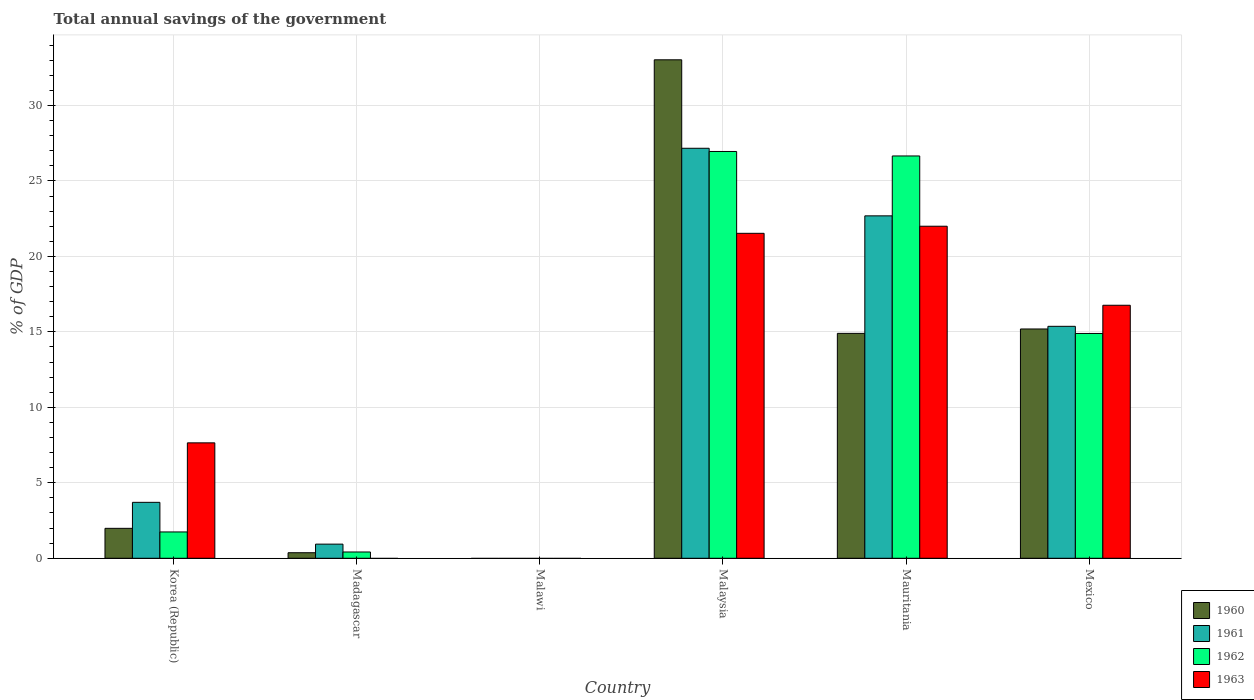How many different coloured bars are there?
Offer a very short reply. 4. Are the number of bars on each tick of the X-axis equal?
Give a very brief answer. No. How many bars are there on the 1st tick from the left?
Your answer should be compact. 4. How many bars are there on the 1st tick from the right?
Your answer should be compact. 4. In how many cases, is the number of bars for a given country not equal to the number of legend labels?
Provide a succinct answer. 2. What is the total annual savings of the government in 1962 in Korea (Republic)?
Give a very brief answer. 1.74. Across all countries, what is the maximum total annual savings of the government in 1962?
Give a very brief answer. 26.95. In which country was the total annual savings of the government in 1960 maximum?
Provide a short and direct response. Malaysia. What is the total total annual savings of the government in 1960 in the graph?
Offer a terse response. 65.47. What is the difference between the total annual savings of the government in 1960 in Korea (Republic) and that in Mexico?
Keep it short and to the point. -13.21. What is the difference between the total annual savings of the government in 1961 in Mexico and the total annual savings of the government in 1960 in Malaysia?
Make the answer very short. -17.66. What is the average total annual savings of the government in 1963 per country?
Provide a succinct answer. 11.32. What is the difference between the total annual savings of the government of/in 1961 and total annual savings of the government of/in 1960 in Korea (Republic)?
Give a very brief answer. 1.72. In how many countries, is the total annual savings of the government in 1961 greater than 30 %?
Keep it short and to the point. 0. What is the ratio of the total annual savings of the government in 1961 in Madagascar to that in Mexico?
Make the answer very short. 0.06. Is the total annual savings of the government in 1961 in Madagascar less than that in Mexico?
Provide a short and direct response. Yes. Is the difference between the total annual savings of the government in 1961 in Malaysia and Mauritania greater than the difference between the total annual savings of the government in 1960 in Malaysia and Mauritania?
Your response must be concise. No. What is the difference between the highest and the second highest total annual savings of the government in 1960?
Your answer should be very brief. 18.13. What is the difference between the highest and the lowest total annual savings of the government in 1960?
Keep it short and to the point. 33.03. Is the sum of the total annual savings of the government in 1962 in Korea (Republic) and Malaysia greater than the maximum total annual savings of the government in 1961 across all countries?
Keep it short and to the point. Yes. Is it the case that in every country, the sum of the total annual savings of the government in 1961 and total annual savings of the government in 1962 is greater than the total annual savings of the government in 1960?
Keep it short and to the point. No. What is the difference between two consecutive major ticks on the Y-axis?
Give a very brief answer. 5. Does the graph contain grids?
Your answer should be compact. Yes. Where does the legend appear in the graph?
Ensure brevity in your answer.  Bottom right. How are the legend labels stacked?
Ensure brevity in your answer.  Vertical. What is the title of the graph?
Provide a short and direct response. Total annual savings of the government. What is the label or title of the X-axis?
Provide a succinct answer. Country. What is the label or title of the Y-axis?
Keep it short and to the point. % of GDP. What is the % of GDP in 1960 in Korea (Republic)?
Offer a very short reply. 1.98. What is the % of GDP in 1961 in Korea (Republic)?
Provide a succinct answer. 3.71. What is the % of GDP of 1962 in Korea (Republic)?
Give a very brief answer. 1.74. What is the % of GDP of 1963 in Korea (Republic)?
Provide a short and direct response. 7.65. What is the % of GDP of 1960 in Madagascar?
Keep it short and to the point. 0.37. What is the % of GDP of 1961 in Madagascar?
Your answer should be compact. 0.94. What is the % of GDP of 1962 in Madagascar?
Your response must be concise. 0.42. What is the % of GDP in 1963 in Madagascar?
Your answer should be compact. 0. What is the % of GDP of 1960 in Malawi?
Your response must be concise. 0. What is the % of GDP in 1961 in Malawi?
Keep it short and to the point. 0. What is the % of GDP of 1960 in Malaysia?
Ensure brevity in your answer.  33.03. What is the % of GDP in 1961 in Malaysia?
Your answer should be very brief. 27.16. What is the % of GDP in 1962 in Malaysia?
Your answer should be compact. 26.95. What is the % of GDP in 1963 in Malaysia?
Your response must be concise. 21.53. What is the % of GDP of 1960 in Mauritania?
Your answer should be very brief. 14.9. What is the % of GDP in 1961 in Mauritania?
Offer a very short reply. 22.69. What is the % of GDP in 1962 in Mauritania?
Provide a short and direct response. 26.65. What is the % of GDP in 1963 in Mauritania?
Ensure brevity in your answer.  22. What is the % of GDP in 1960 in Mexico?
Ensure brevity in your answer.  15.19. What is the % of GDP of 1961 in Mexico?
Your answer should be very brief. 15.37. What is the % of GDP of 1962 in Mexico?
Offer a very short reply. 14.89. What is the % of GDP of 1963 in Mexico?
Provide a short and direct response. 16.76. Across all countries, what is the maximum % of GDP in 1960?
Your answer should be very brief. 33.03. Across all countries, what is the maximum % of GDP in 1961?
Your answer should be very brief. 27.16. Across all countries, what is the maximum % of GDP of 1962?
Give a very brief answer. 26.95. Across all countries, what is the maximum % of GDP in 1963?
Your answer should be very brief. 22. Across all countries, what is the minimum % of GDP in 1961?
Ensure brevity in your answer.  0. Across all countries, what is the minimum % of GDP in 1962?
Your answer should be very brief. 0. Across all countries, what is the minimum % of GDP in 1963?
Your response must be concise. 0. What is the total % of GDP of 1960 in the graph?
Provide a succinct answer. 65.47. What is the total % of GDP of 1961 in the graph?
Offer a terse response. 69.86. What is the total % of GDP in 1962 in the graph?
Provide a short and direct response. 70.66. What is the total % of GDP in 1963 in the graph?
Offer a terse response. 67.94. What is the difference between the % of GDP in 1960 in Korea (Republic) and that in Madagascar?
Your response must be concise. 1.62. What is the difference between the % of GDP in 1961 in Korea (Republic) and that in Madagascar?
Make the answer very short. 2.77. What is the difference between the % of GDP of 1962 in Korea (Republic) and that in Madagascar?
Provide a succinct answer. 1.33. What is the difference between the % of GDP of 1960 in Korea (Republic) and that in Malaysia?
Offer a very short reply. -31.04. What is the difference between the % of GDP of 1961 in Korea (Republic) and that in Malaysia?
Make the answer very short. -23.46. What is the difference between the % of GDP of 1962 in Korea (Republic) and that in Malaysia?
Give a very brief answer. -25.21. What is the difference between the % of GDP of 1963 in Korea (Republic) and that in Malaysia?
Offer a very short reply. -13.88. What is the difference between the % of GDP of 1960 in Korea (Republic) and that in Mauritania?
Keep it short and to the point. -12.92. What is the difference between the % of GDP in 1961 in Korea (Republic) and that in Mauritania?
Provide a short and direct response. -18.98. What is the difference between the % of GDP of 1962 in Korea (Republic) and that in Mauritania?
Ensure brevity in your answer.  -24.91. What is the difference between the % of GDP in 1963 in Korea (Republic) and that in Mauritania?
Your answer should be compact. -14.35. What is the difference between the % of GDP of 1960 in Korea (Republic) and that in Mexico?
Your answer should be compact. -13.21. What is the difference between the % of GDP of 1961 in Korea (Republic) and that in Mexico?
Offer a terse response. -11.66. What is the difference between the % of GDP of 1962 in Korea (Republic) and that in Mexico?
Your answer should be very brief. -13.15. What is the difference between the % of GDP in 1963 in Korea (Republic) and that in Mexico?
Give a very brief answer. -9.12. What is the difference between the % of GDP of 1960 in Madagascar and that in Malaysia?
Offer a very short reply. -32.66. What is the difference between the % of GDP in 1961 in Madagascar and that in Malaysia?
Make the answer very short. -26.23. What is the difference between the % of GDP in 1962 in Madagascar and that in Malaysia?
Your response must be concise. -26.53. What is the difference between the % of GDP in 1960 in Madagascar and that in Mauritania?
Your answer should be compact. -14.53. What is the difference between the % of GDP in 1961 in Madagascar and that in Mauritania?
Keep it short and to the point. -21.75. What is the difference between the % of GDP in 1962 in Madagascar and that in Mauritania?
Offer a terse response. -26.24. What is the difference between the % of GDP of 1960 in Madagascar and that in Mexico?
Your answer should be very brief. -14.82. What is the difference between the % of GDP in 1961 in Madagascar and that in Mexico?
Your answer should be compact. -14.43. What is the difference between the % of GDP of 1962 in Madagascar and that in Mexico?
Your response must be concise. -14.48. What is the difference between the % of GDP in 1960 in Malaysia and that in Mauritania?
Offer a terse response. 18.13. What is the difference between the % of GDP in 1961 in Malaysia and that in Mauritania?
Give a very brief answer. 4.48. What is the difference between the % of GDP of 1962 in Malaysia and that in Mauritania?
Your answer should be very brief. 0.3. What is the difference between the % of GDP in 1963 in Malaysia and that in Mauritania?
Offer a terse response. -0.47. What is the difference between the % of GDP of 1960 in Malaysia and that in Mexico?
Offer a terse response. 17.83. What is the difference between the % of GDP in 1961 in Malaysia and that in Mexico?
Your response must be concise. 11.8. What is the difference between the % of GDP in 1962 in Malaysia and that in Mexico?
Give a very brief answer. 12.06. What is the difference between the % of GDP in 1963 in Malaysia and that in Mexico?
Offer a terse response. 4.77. What is the difference between the % of GDP of 1960 in Mauritania and that in Mexico?
Make the answer very short. -0.29. What is the difference between the % of GDP of 1961 in Mauritania and that in Mexico?
Give a very brief answer. 7.32. What is the difference between the % of GDP in 1962 in Mauritania and that in Mexico?
Provide a succinct answer. 11.76. What is the difference between the % of GDP in 1963 in Mauritania and that in Mexico?
Provide a succinct answer. 5.24. What is the difference between the % of GDP in 1960 in Korea (Republic) and the % of GDP in 1961 in Madagascar?
Your answer should be very brief. 1.05. What is the difference between the % of GDP of 1960 in Korea (Republic) and the % of GDP of 1962 in Madagascar?
Make the answer very short. 1.57. What is the difference between the % of GDP of 1961 in Korea (Republic) and the % of GDP of 1962 in Madagascar?
Keep it short and to the point. 3.29. What is the difference between the % of GDP in 1960 in Korea (Republic) and the % of GDP in 1961 in Malaysia?
Keep it short and to the point. -25.18. What is the difference between the % of GDP in 1960 in Korea (Republic) and the % of GDP in 1962 in Malaysia?
Give a very brief answer. -24.97. What is the difference between the % of GDP in 1960 in Korea (Republic) and the % of GDP in 1963 in Malaysia?
Your answer should be compact. -19.55. What is the difference between the % of GDP of 1961 in Korea (Republic) and the % of GDP of 1962 in Malaysia?
Provide a succinct answer. -23.24. What is the difference between the % of GDP in 1961 in Korea (Republic) and the % of GDP in 1963 in Malaysia?
Offer a terse response. -17.82. What is the difference between the % of GDP in 1962 in Korea (Republic) and the % of GDP in 1963 in Malaysia?
Your answer should be very brief. -19.79. What is the difference between the % of GDP of 1960 in Korea (Republic) and the % of GDP of 1961 in Mauritania?
Your answer should be compact. -20.7. What is the difference between the % of GDP in 1960 in Korea (Republic) and the % of GDP in 1962 in Mauritania?
Your answer should be compact. -24.67. What is the difference between the % of GDP of 1960 in Korea (Republic) and the % of GDP of 1963 in Mauritania?
Your answer should be compact. -20.02. What is the difference between the % of GDP of 1961 in Korea (Republic) and the % of GDP of 1962 in Mauritania?
Make the answer very short. -22.95. What is the difference between the % of GDP in 1961 in Korea (Republic) and the % of GDP in 1963 in Mauritania?
Your response must be concise. -18.29. What is the difference between the % of GDP in 1962 in Korea (Republic) and the % of GDP in 1963 in Mauritania?
Offer a terse response. -20.25. What is the difference between the % of GDP of 1960 in Korea (Republic) and the % of GDP of 1961 in Mexico?
Give a very brief answer. -13.38. What is the difference between the % of GDP of 1960 in Korea (Republic) and the % of GDP of 1962 in Mexico?
Keep it short and to the point. -12.91. What is the difference between the % of GDP of 1960 in Korea (Republic) and the % of GDP of 1963 in Mexico?
Provide a short and direct response. -14.78. What is the difference between the % of GDP in 1961 in Korea (Republic) and the % of GDP in 1962 in Mexico?
Provide a succinct answer. -11.19. What is the difference between the % of GDP of 1961 in Korea (Republic) and the % of GDP of 1963 in Mexico?
Provide a short and direct response. -13.06. What is the difference between the % of GDP in 1962 in Korea (Republic) and the % of GDP in 1963 in Mexico?
Your response must be concise. -15.02. What is the difference between the % of GDP of 1960 in Madagascar and the % of GDP of 1961 in Malaysia?
Provide a succinct answer. -26.8. What is the difference between the % of GDP of 1960 in Madagascar and the % of GDP of 1962 in Malaysia?
Ensure brevity in your answer.  -26.58. What is the difference between the % of GDP of 1960 in Madagascar and the % of GDP of 1963 in Malaysia?
Your answer should be compact. -21.16. What is the difference between the % of GDP of 1961 in Madagascar and the % of GDP of 1962 in Malaysia?
Make the answer very short. -26.01. What is the difference between the % of GDP of 1961 in Madagascar and the % of GDP of 1963 in Malaysia?
Offer a very short reply. -20.59. What is the difference between the % of GDP of 1962 in Madagascar and the % of GDP of 1963 in Malaysia?
Provide a short and direct response. -21.11. What is the difference between the % of GDP of 1960 in Madagascar and the % of GDP of 1961 in Mauritania?
Your answer should be very brief. -22.32. What is the difference between the % of GDP in 1960 in Madagascar and the % of GDP in 1962 in Mauritania?
Your answer should be compact. -26.29. What is the difference between the % of GDP in 1960 in Madagascar and the % of GDP in 1963 in Mauritania?
Your answer should be compact. -21.63. What is the difference between the % of GDP of 1961 in Madagascar and the % of GDP of 1962 in Mauritania?
Make the answer very short. -25.72. What is the difference between the % of GDP of 1961 in Madagascar and the % of GDP of 1963 in Mauritania?
Your answer should be compact. -21.06. What is the difference between the % of GDP in 1962 in Madagascar and the % of GDP in 1963 in Mauritania?
Give a very brief answer. -21.58. What is the difference between the % of GDP of 1960 in Madagascar and the % of GDP of 1961 in Mexico?
Your answer should be compact. -15. What is the difference between the % of GDP in 1960 in Madagascar and the % of GDP in 1962 in Mexico?
Offer a very short reply. -14.53. What is the difference between the % of GDP of 1960 in Madagascar and the % of GDP of 1963 in Mexico?
Provide a short and direct response. -16.4. What is the difference between the % of GDP in 1961 in Madagascar and the % of GDP in 1962 in Mexico?
Offer a terse response. -13.96. What is the difference between the % of GDP of 1961 in Madagascar and the % of GDP of 1963 in Mexico?
Offer a very short reply. -15.83. What is the difference between the % of GDP in 1962 in Madagascar and the % of GDP in 1963 in Mexico?
Keep it short and to the point. -16.35. What is the difference between the % of GDP in 1960 in Malaysia and the % of GDP in 1961 in Mauritania?
Your answer should be very brief. 10.34. What is the difference between the % of GDP in 1960 in Malaysia and the % of GDP in 1962 in Mauritania?
Make the answer very short. 6.37. What is the difference between the % of GDP of 1960 in Malaysia and the % of GDP of 1963 in Mauritania?
Give a very brief answer. 11.03. What is the difference between the % of GDP in 1961 in Malaysia and the % of GDP in 1962 in Mauritania?
Give a very brief answer. 0.51. What is the difference between the % of GDP in 1961 in Malaysia and the % of GDP in 1963 in Mauritania?
Offer a very short reply. 5.17. What is the difference between the % of GDP in 1962 in Malaysia and the % of GDP in 1963 in Mauritania?
Ensure brevity in your answer.  4.95. What is the difference between the % of GDP in 1960 in Malaysia and the % of GDP in 1961 in Mexico?
Keep it short and to the point. 17.66. What is the difference between the % of GDP in 1960 in Malaysia and the % of GDP in 1962 in Mexico?
Provide a short and direct response. 18.13. What is the difference between the % of GDP of 1960 in Malaysia and the % of GDP of 1963 in Mexico?
Keep it short and to the point. 16.26. What is the difference between the % of GDP in 1961 in Malaysia and the % of GDP in 1962 in Mexico?
Give a very brief answer. 12.27. What is the difference between the % of GDP of 1961 in Malaysia and the % of GDP of 1963 in Mexico?
Offer a very short reply. 10.4. What is the difference between the % of GDP of 1962 in Malaysia and the % of GDP of 1963 in Mexico?
Ensure brevity in your answer.  10.19. What is the difference between the % of GDP in 1960 in Mauritania and the % of GDP in 1961 in Mexico?
Provide a succinct answer. -0.47. What is the difference between the % of GDP in 1960 in Mauritania and the % of GDP in 1962 in Mexico?
Give a very brief answer. 0.01. What is the difference between the % of GDP of 1960 in Mauritania and the % of GDP of 1963 in Mexico?
Your response must be concise. -1.86. What is the difference between the % of GDP of 1961 in Mauritania and the % of GDP of 1962 in Mexico?
Offer a very short reply. 7.79. What is the difference between the % of GDP in 1961 in Mauritania and the % of GDP in 1963 in Mexico?
Keep it short and to the point. 5.92. What is the difference between the % of GDP of 1962 in Mauritania and the % of GDP of 1963 in Mexico?
Your answer should be compact. 9.89. What is the average % of GDP in 1960 per country?
Your answer should be very brief. 10.91. What is the average % of GDP of 1961 per country?
Ensure brevity in your answer.  11.64. What is the average % of GDP of 1962 per country?
Give a very brief answer. 11.78. What is the average % of GDP of 1963 per country?
Offer a terse response. 11.32. What is the difference between the % of GDP in 1960 and % of GDP in 1961 in Korea (Republic)?
Your response must be concise. -1.72. What is the difference between the % of GDP in 1960 and % of GDP in 1962 in Korea (Republic)?
Make the answer very short. 0.24. What is the difference between the % of GDP in 1960 and % of GDP in 1963 in Korea (Republic)?
Ensure brevity in your answer.  -5.66. What is the difference between the % of GDP in 1961 and % of GDP in 1962 in Korea (Republic)?
Give a very brief answer. 1.96. What is the difference between the % of GDP of 1961 and % of GDP of 1963 in Korea (Republic)?
Offer a terse response. -3.94. What is the difference between the % of GDP of 1962 and % of GDP of 1963 in Korea (Republic)?
Keep it short and to the point. -5.9. What is the difference between the % of GDP of 1960 and % of GDP of 1961 in Madagascar?
Keep it short and to the point. -0.57. What is the difference between the % of GDP in 1960 and % of GDP in 1962 in Madagascar?
Offer a terse response. -0.05. What is the difference between the % of GDP of 1961 and % of GDP of 1962 in Madagascar?
Provide a short and direct response. 0.52. What is the difference between the % of GDP of 1960 and % of GDP of 1961 in Malaysia?
Make the answer very short. 5.86. What is the difference between the % of GDP of 1960 and % of GDP of 1962 in Malaysia?
Provide a short and direct response. 6.07. What is the difference between the % of GDP in 1960 and % of GDP in 1963 in Malaysia?
Offer a very short reply. 11.5. What is the difference between the % of GDP of 1961 and % of GDP of 1962 in Malaysia?
Keep it short and to the point. 0.21. What is the difference between the % of GDP of 1961 and % of GDP of 1963 in Malaysia?
Provide a succinct answer. 5.63. What is the difference between the % of GDP of 1962 and % of GDP of 1963 in Malaysia?
Your answer should be compact. 5.42. What is the difference between the % of GDP in 1960 and % of GDP in 1961 in Mauritania?
Your answer should be very brief. -7.79. What is the difference between the % of GDP of 1960 and % of GDP of 1962 in Mauritania?
Your answer should be compact. -11.75. What is the difference between the % of GDP in 1960 and % of GDP in 1963 in Mauritania?
Provide a short and direct response. -7.1. What is the difference between the % of GDP in 1961 and % of GDP in 1962 in Mauritania?
Provide a succinct answer. -3.97. What is the difference between the % of GDP of 1961 and % of GDP of 1963 in Mauritania?
Make the answer very short. 0.69. What is the difference between the % of GDP in 1962 and % of GDP in 1963 in Mauritania?
Your response must be concise. 4.66. What is the difference between the % of GDP in 1960 and % of GDP in 1961 in Mexico?
Your response must be concise. -0.18. What is the difference between the % of GDP of 1960 and % of GDP of 1962 in Mexico?
Keep it short and to the point. 0.3. What is the difference between the % of GDP of 1960 and % of GDP of 1963 in Mexico?
Make the answer very short. -1.57. What is the difference between the % of GDP of 1961 and % of GDP of 1962 in Mexico?
Your answer should be compact. 0.47. What is the difference between the % of GDP of 1961 and % of GDP of 1963 in Mexico?
Give a very brief answer. -1.4. What is the difference between the % of GDP in 1962 and % of GDP in 1963 in Mexico?
Your answer should be very brief. -1.87. What is the ratio of the % of GDP of 1960 in Korea (Republic) to that in Madagascar?
Your answer should be very brief. 5.4. What is the ratio of the % of GDP of 1961 in Korea (Republic) to that in Madagascar?
Keep it short and to the point. 3.96. What is the ratio of the % of GDP in 1962 in Korea (Republic) to that in Madagascar?
Offer a very short reply. 4.19. What is the ratio of the % of GDP of 1960 in Korea (Republic) to that in Malaysia?
Your answer should be very brief. 0.06. What is the ratio of the % of GDP of 1961 in Korea (Republic) to that in Malaysia?
Provide a short and direct response. 0.14. What is the ratio of the % of GDP in 1962 in Korea (Republic) to that in Malaysia?
Keep it short and to the point. 0.06. What is the ratio of the % of GDP of 1963 in Korea (Republic) to that in Malaysia?
Give a very brief answer. 0.36. What is the ratio of the % of GDP in 1960 in Korea (Republic) to that in Mauritania?
Give a very brief answer. 0.13. What is the ratio of the % of GDP of 1961 in Korea (Republic) to that in Mauritania?
Your answer should be very brief. 0.16. What is the ratio of the % of GDP of 1962 in Korea (Republic) to that in Mauritania?
Give a very brief answer. 0.07. What is the ratio of the % of GDP in 1963 in Korea (Republic) to that in Mauritania?
Offer a terse response. 0.35. What is the ratio of the % of GDP of 1960 in Korea (Republic) to that in Mexico?
Ensure brevity in your answer.  0.13. What is the ratio of the % of GDP in 1961 in Korea (Republic) to that in Mexico?
Your response must be concise. 0.24. What is the ratio of the % of GDP of 1962 in Korea (Republic) to that in Mexico?
Your answer should be compact. 0.12. What is the ratio of the % of GDP of 1963 in Korea (Republic) to that in Mexico?
Provide a short and direct response. 0.46. What is the ratio of the % of GDP of 1960 in Madagascar to that in Malaysia?
Make the answer very short. 0.01. What is the ratio of the % of GDP of 1961 in Madagascar to that in Malaysia?
Provide a succinct answer. 0.03. What is the ratio of the % of GDP in 1962 in Madagascar to that in Malaysia?
Provide a succinct answer. 0.02. What is the ratio of the % of GDP of 1960 in Madagascar to that in Mauritania?
Your response must be concise. 0.02. What is the ratio of the % of GDP of 1961 in Madagascar to that in Mauritania?
Your response must be concise. 0.04. What is the ratio of the % of GDP in 1962 in Madagascar to that in Mauritania?
Offer a terse response. 0.02. What is the ratio of the % of GDP in 1960 in Madagascar to that in Mexico?
Your answer should be compact. 0.02. What is the ratio of the % of GDP in 1961 in Madagascar to that in Mexico?
Offer a terse response. 0.06. What is the ratio of the % of GDP in 1962 in Madagascar to that in Mexico?
Your answer should be very brief. 0.03. What is the ratio of the % of GDP of 1960 in Malaysia to that in Mauritania?
Make the answer very short. 2.22. What is the ratio of the % of GDP in 1961 in Malaysia to that in Mauritania?
Your answer should be compact. 1.2. What is the ratio of the % of GDP of 1962 in Malaysia to that in Mauritania?
Give a very brief answer. 1.01. What is the ratio of the % of GDP of 1963 in Malaysia to that in Mauritania?
Keep it short and to the point. 0.98. What is the ratio of the % of GDP in 1960 in Malaysia to that in Mexico?
Make the answer very short. 2.17. What is the ratio of the % of GDP in 1961 in Malaysia to that in Mexico?
Provide a short and direct response. 1.77. What is the ratio of the % of GDP in 1962 in Malaysia to that in Mexico?
Offer a very short reply. 1.81. What is the ratio of the % of GDP of 1963 in Malaysia to that in Mexico?
Your response must be concise. 1.28. What is the ratio of the % of GDP of 1960 in Mauritania to that in Mexico?
Keep it short and to the point. 0.98. What is the ratio of the % of GDP of 1961 in Mauritania to that in Mexico?
Ensure brevity in your answer.  1.48. What is the ratio of the % of GDP in 1962 in Mauritania to that in Mexico?
Your response must be concise. 1.79. What is the ratio of the % of GDP in 1963 in Mauritania to that in Mexico?
Your answer should be very brief. 1.31. What is the difference between the highest and the second highest % of GDP in 1960?
Give a very brief answer. 17.83. What is the difference between the highest and the second highest % of GDP in 1961?
Offer a terse response. 4.48. What is the difference between the highest and the second highest % of GDP in 1962?
Offer a very short reply. 0.3. What is the difference between the highest and the second highest % of GDP in 1963?
Offer a very short reply. 0.47. What is the difference between the highest and the lowest % of GDP in 1960?
Ensure brevity in your answer.  33.03. What is the difference between the highest and the lowest % of GDP of 1961?
Your answer should be very brief. 27.16. What is the difference between the highest and the lowest % of GDP in 1962?
Make the answer very short. 26.95. What is the difference between the highest and the lowest % of GDP in 1963?
Provide a short and direct response. 22. 